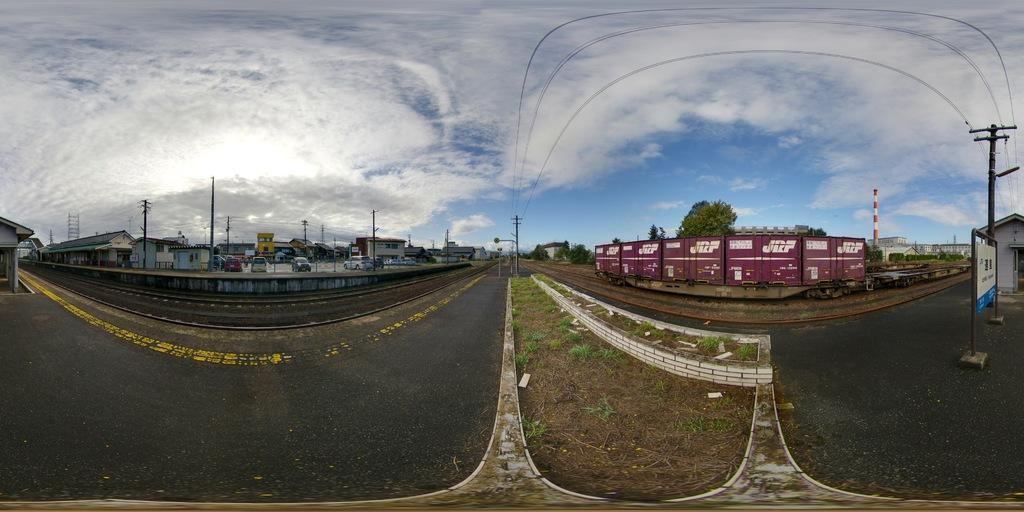Can you describe this image briefly? In this picture we can see a railway track, cars, poles, buildings, trees, a train, wires, grass and the sky. 